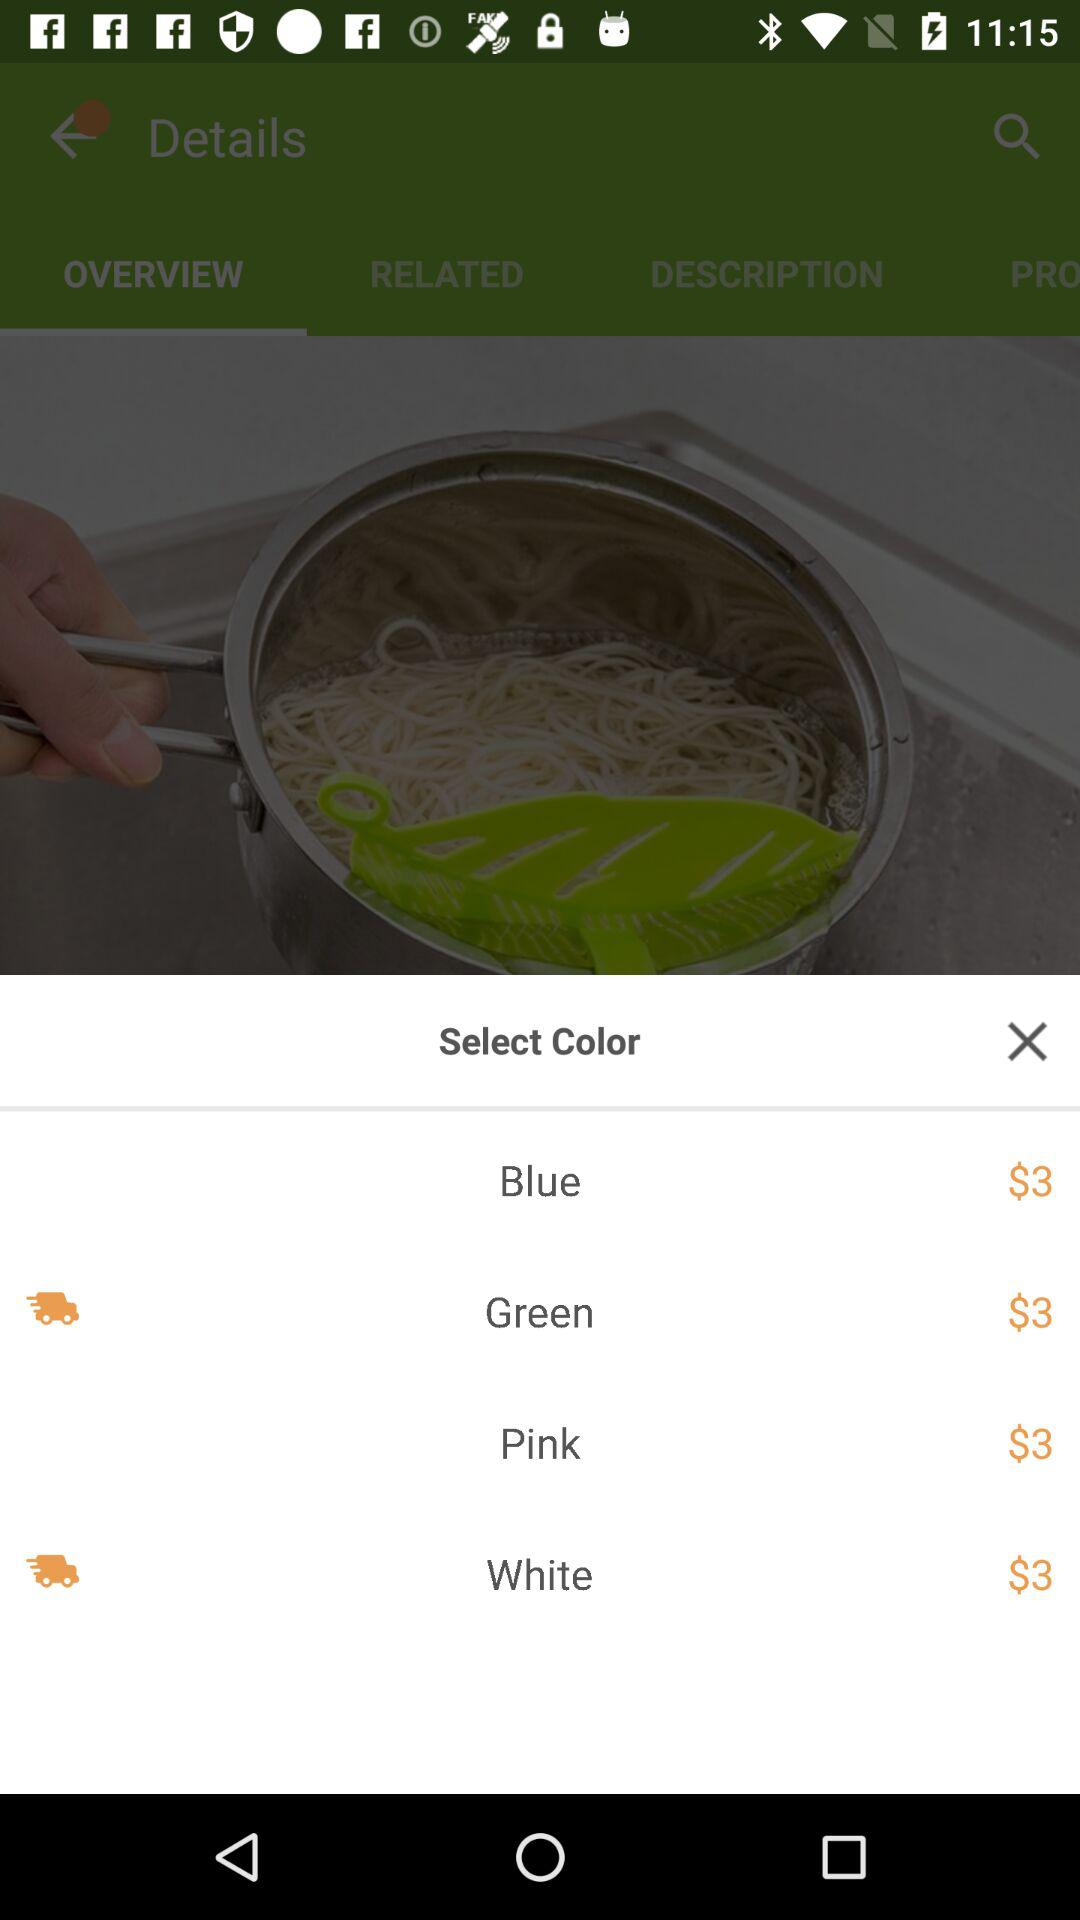What is the price of the product in the blue color? The price of the product in the blue color is $3. 